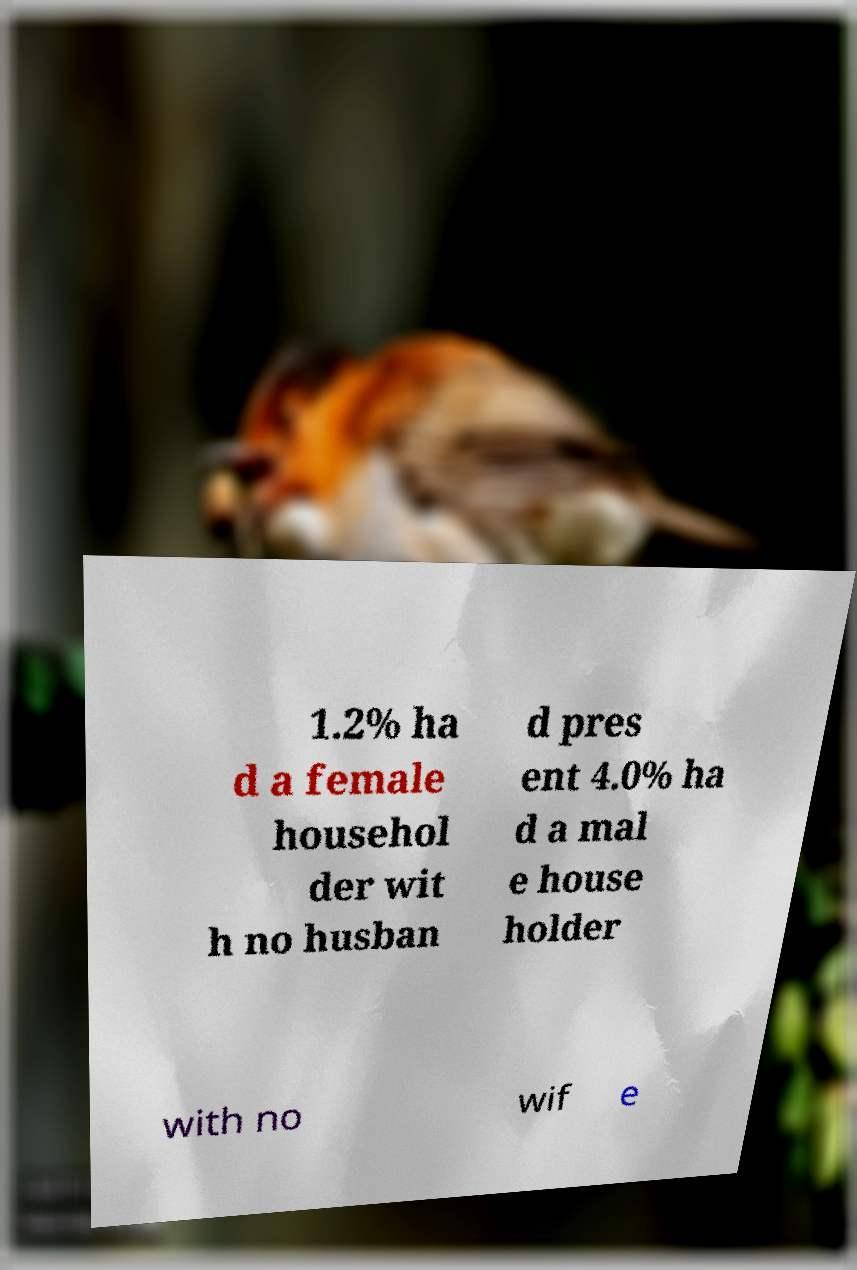Please read and relay the text visible in this image. What does it say? 1.2% ha d a female househol der wit h no husban d pres ent 4.0% ha d a mal e house holder with no wif e 